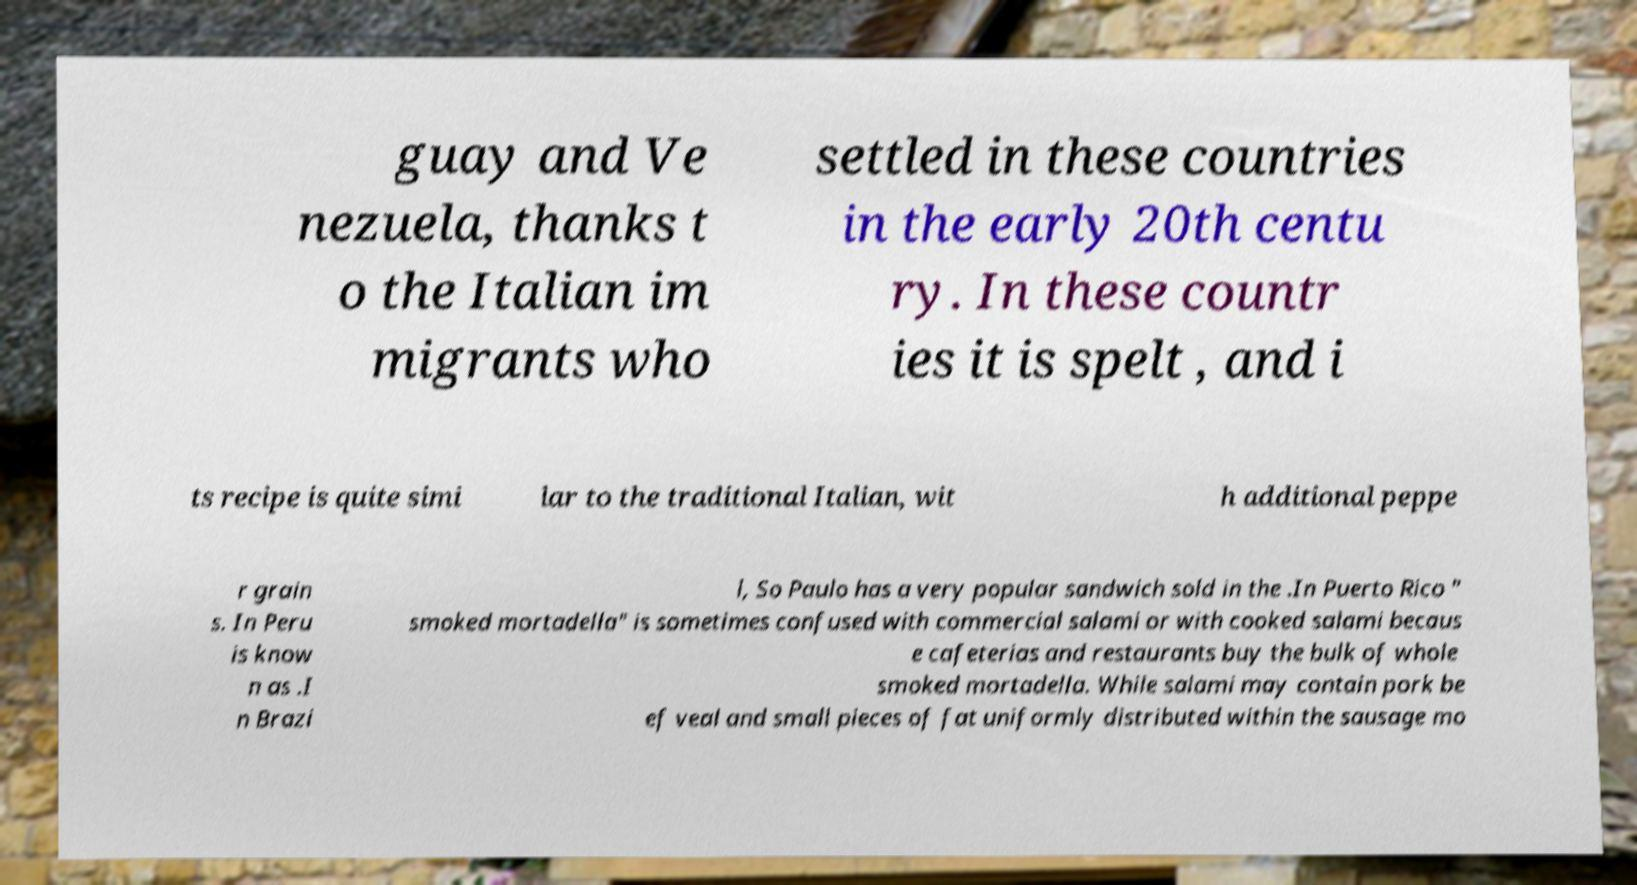Please read and relay the text visible in this image. What does it say? guay and Ve nezuela, thanks t o the Italian im migrants who settled in these countries in the early 20th centu ry. In these countr ies it is spelt , and i ts recipe is quite simi lar to the traditional Italian, wit h additional peppe r grain s. In Peru is know n as .I n Brazi l, So Paulo has a very popular sandwich sold in the .In Puerto Rico " smoked mortadella" is sometimes confused with commercial salami or with cooked salami becaus e cafeterias and restaurants buy the bulk of whole smoked mortadella. While salami may contain pork be ef veal and small pieces of fat uniformly distributed within the sausage mo 